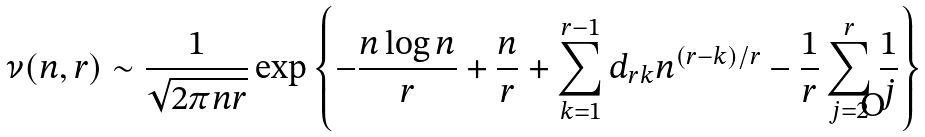Convert formula to latex. <formula><loc_0><loc_0><loc_500><loc_500>\nu ( n , r ) \sim \frac { 1 } { \sqrt { 2 \pi n r } } \exp \left \{ - \frac { n \log n } { r } + \frac { n } { r } + \sum _ { k = 1 } ^ { r - 1 } d _ { r k } n ^ { ( r - k ) / r } - \frac { 1 } { r } \sum _ { j = 2 } ^ { r } \frac { 1 } { j } \right \}</formula> 